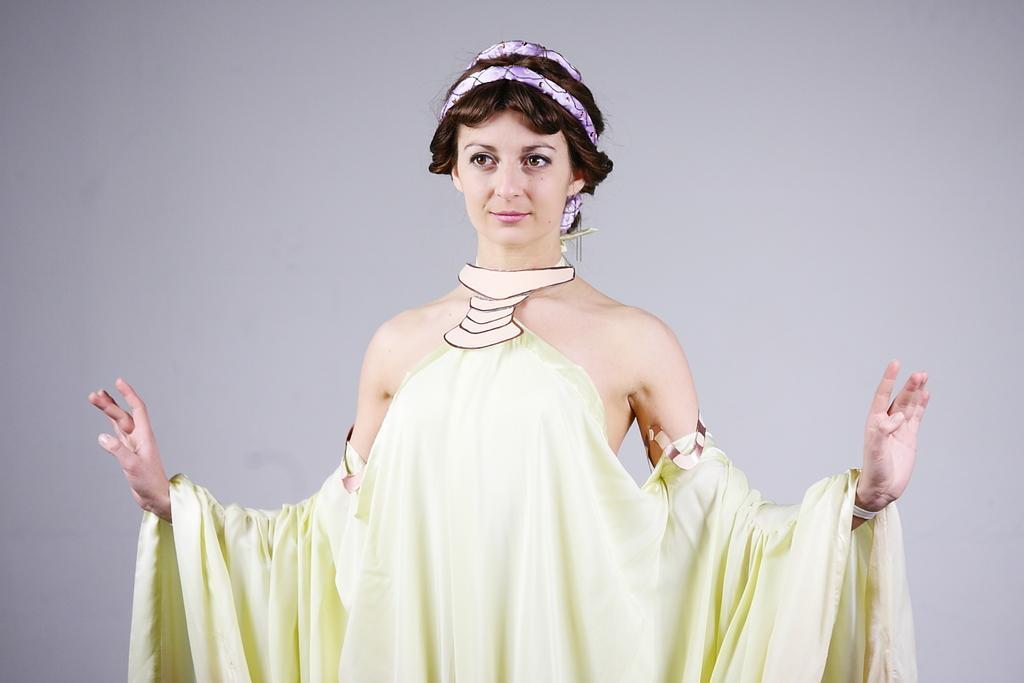In one or two sentences, can you explain what this image depicts? There is one woman standing as we can see in the middle of this image and there is a wall in the background. 